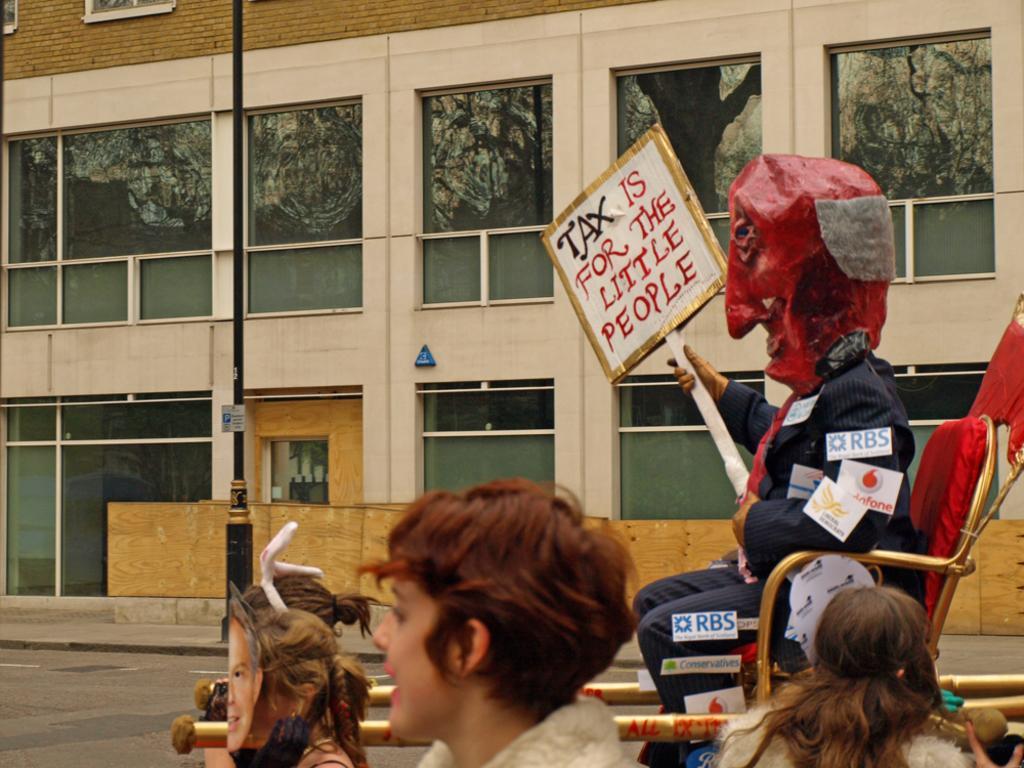How would you summarize this image in a sentence or two? In this image, we can see a few people. Few are holding some objects and board. Here a person is sitting on a chair. We can see some stickers. Here there is a road. Background we can see a building, walls, glass windows, pole, sign boards, brick wall. 